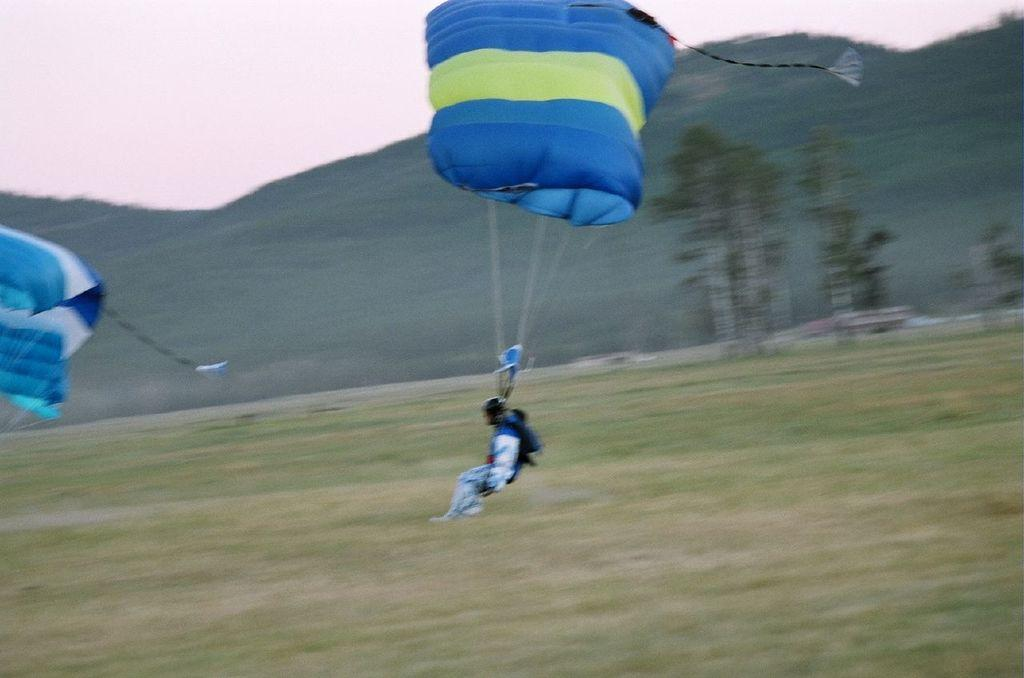What is the main subject of the image? The main subject of the image is a person flying on a parachute. What type of landscape can be seen in the image? Hills are visible in the image. What other natural elements can be seen in the image? There are trees in the image. What is visible in the background of the image? The sky is visible in the image. How many women are visible in the image? There is no mention of women in the image; the main subject is a person flying on a parachute. What type of teeth can be seen in the image? There are no teeth visible in the image. 